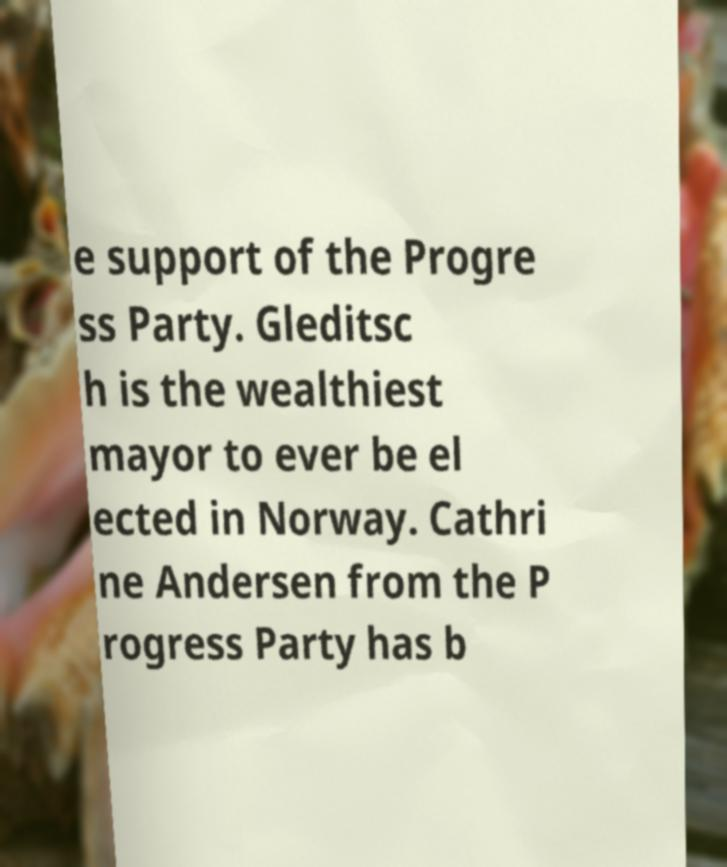For documentation purposes, I need the text within this image transcribed. Could you provide that? e support of the Progre ss Party. Gleditsc h is the wealthiest mayor to ever be el ected in Norway. Cathri ne Andersen from the P rogress Party has b 